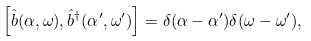Convert formula to latex. <formula><loc_0><loc_0><loc_500><loc_500>\left [ \hat { b } ( \alpha , \omega ) , \hat { b } ^ { \dagger } ( \alpha ^ { \prime } , \omega ^ { \prime } ) \right ] = \delta ( \alpha - \alpha ^ { \prime } ) \delta ( \omega - \omega ^ { \prime } ) ,</formula> 